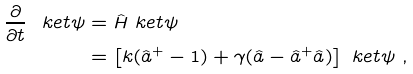<formula> <loc_0><loc_0><loc_500><loc_500>\frac { \partial } { \partial t } \ k e t { \psi } & = \hat { H } \ k e t { \psi } \\ & = \left [ k ( \hat { a } ^ { + } - 1 ) + \gamma ( \hat { a } - \hat { a } ^ { + } \hat { a } ) \right ] \ k e t { \psi } \ ,</formula> 